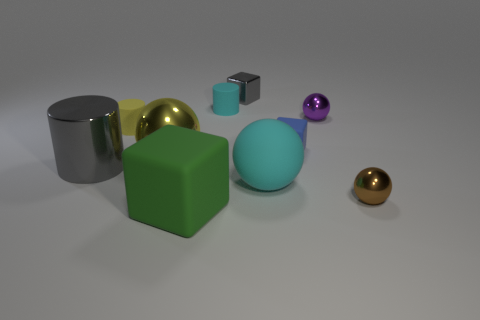There is another large object that is the same shape as the blue matte object; what is its material?
Give a very brief answer. Rubber. What number of big cyan things are left of the ball left of the big green block?
Provide a short and direct response. 0. There is a rubber thing in front of the cyan object in front of the cyan object that is behind the matte sphere; how big is it?
Provide a short and direct response. Large. There is a ball that is behind the sphere left of the tiny gray shiny thing; what color is it?
Your answer should be very brief. Purple. What number of other things are there of the same material as the gray cube
Provide a succinct answer. 4. How many other things are there of the same color as the large block?
Give a very brief answer. 0. What material is the gray object that is to the left of the rubber cylinder that is behind the tiny purple metallic thing?
Provide a succinct answer. Metal. Are there any red spheres?
Provide a short and direct response. No. What size is the gray object in front of the tiny metallic thing that is to the left of the large matte sphere?
Make the answer very short. Large. Are there more small objects that are to the left of the tiny gray metallic thing than yellow cylinders in front of the green thing?
Provide a succinct answer. Yes. 